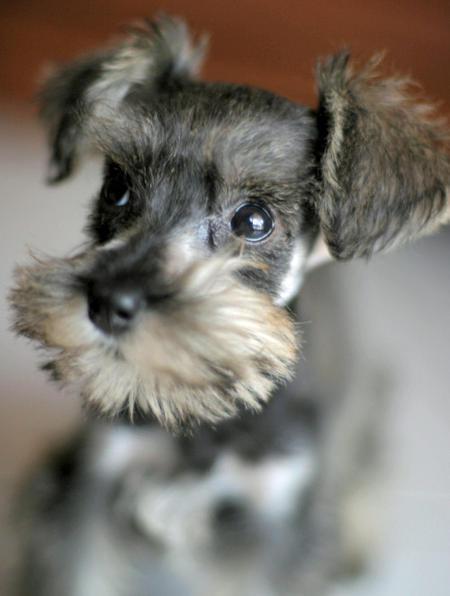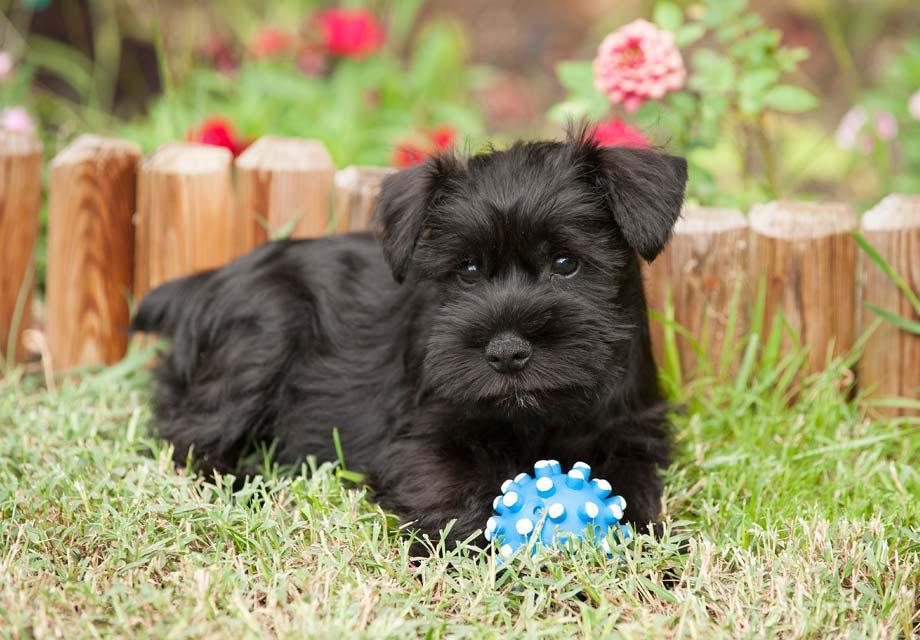The first image is the image on the left, the second image is the image on the right. Evaluate the accuracy of this statement regarding the images: "An image shows a black-faced schnauzer with something blue by its front paws.". Is it true? Answer yes or no. Yes. The first image is the image on the left, the second image is the image on the right. For the images shown, is this caption "One of the dogs is sitting on a wooden floor." true? Answer yes or no. No. 